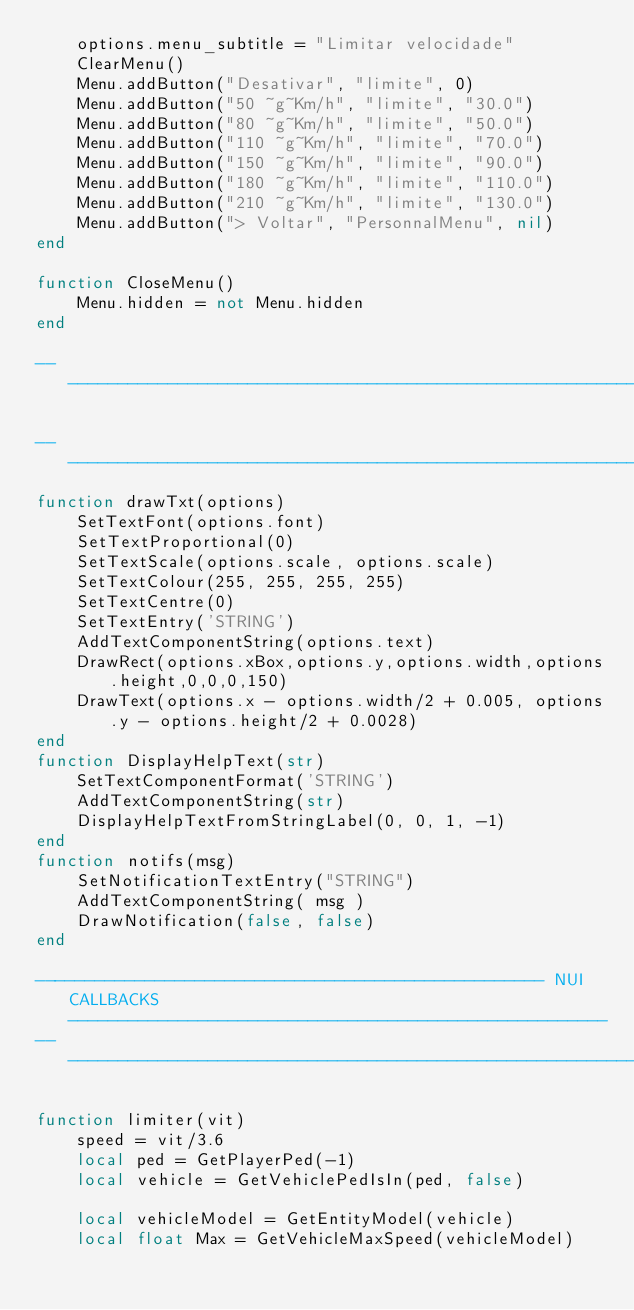<code> <loc_0><loc_0><loc_500><loc_500><_Lua_>    options.menu_subtitle = "Limitar velocidade"
    ClearMenu()
    Menu.addButton("Desativar", "limite", 0)
    Menu.addButton("50 ~g~Km/h", "limite", "30.0")
    Menu.addButton("80 ~g~Km/h", "limite", "50.0")
    Menu.addButton("110 ~g~Km/h", "limite", "70.0")
    Menu.addButton("150 ~g~Km/h", "limite", "90.0")
    Menu.addButton("180 ~g~Km/h", "limite", "110.0")
    Menu.addButton("210 ~g~Km/h", "limite", "130.0")
    Menu.addButton("> Voltar", "PersonnalMenu", nil)
end

function CloseMenu()
    Menu.hidden = not Menu.hidden
end

------------------------------------------------------------------------------------------------------------------------

----------------------------------------------------------------------------------------------------------------------
function drawTxt(options)
    SetTextFont(options.font)
    SetTextProportional(0)
    SetTextScale(options.scale, options.scale)
    SetTextColour(255, 255, 255, 255)
    SetTextCentre(0)
    SetTextEntry('STRING')
    AddTextComponentString(options.text)
    DrawRect(options.xBox,options.y,options.width,options.height,0,0,0,150)
    DrawText(options.x - options.width/2 + 0.005, options.y - options.height/2 + 0.0028)
end
function DisplayHelpText(str)
    SetTextComponentFormat('STRING')
    AddTextComponentString(str)
    DisplayHelpTextFromStringLabel(0, 0, 1, -1)
end
function notifs(msg)
    SetNotificationTextEntry("STRING")
    AddTextComponentString( msg )
    DrawNotification(false, false)
end

--------------------------------------------------- NUI CALLBACKS ------------------------------------------------------
------------------------------------------------------------------------------------------------------------------------

function limiter(vit)
    speed = vit/3.6
    local ped = GetPlayerPed(-1)
    local vehicle = GetVehiclePedIsIn(ped, false)
   
    local vehicleModel = GetEntityModel(vehicle)
    local float Max = GetVehicleMaxSpeed(vehicleModel)
   </code> 